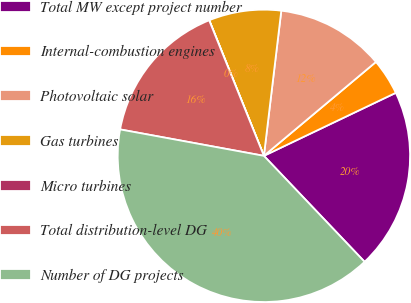<chart> <loc_0><loc_0><loc_500><loc_500><pie_chart><fcel>Total MW except project number<fcel>Internal-combustion engines<fcel>Photovoltaic solar<fcel>Gas turbines<fcel>Micro turbines<fcel>Total distribution-level DG<fcel>Number of DG projects<nl><fcel>20.0%<fcel>4.01%<fcel>12.0%<fcel>8.0%<fcel>0.01%<fcel>16.0%<fcel>39.99%<nl></chart> 